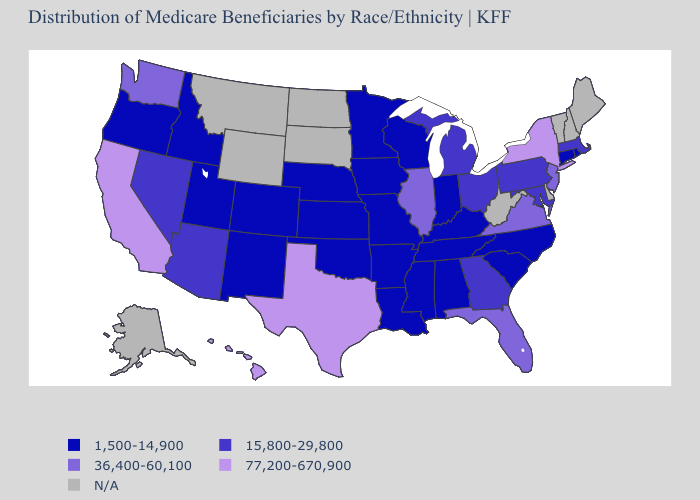Among the states that border Missouri , which have the highest value?
Short answer required. Illinois. Name the states that have a value in the range 77,200-670,900?
Give a very brief answer. California, Hawaii, New York, Texas. Which states have the lowest value in the West?
Answer briefly. Colorado, Idaho, New Mexico, Oregon, Utah. Name the states that have a value in the range 15,800-29,800?
Give a very brief answer. Arizona, Georgia, Maryland, Massachusetts, Michigan, Nevada, Ohio, Pennsylvania. What is the value of Kentucky?
Write a very short answer. 1,500-14,900. Name the states that have a value in the range 1,500-14,900?
Short answer required. Alabama, Arkansas, Colorado, Connecticut, Idaho, Indiana, Iowa, Kansas, Kentucky, Louisiana, Minnesota, Mississippi, Missouri, Nebraska, New Mexico, North Carolina, Oklahoma, Oregon, Rhode Island, South Carolina, Tennessee, Utah, Wisconsin. Which states have the lowest value in the USA?
Quick response, please. Alabama, Arkansas, Colorado, Connecticut, Idaho, Indiana, Iowa, Kansas, Kentucky, Louisiana, Minnesota, Mississippi, Missouri, Nebraska, New Mexico, North Carolina, Oklahoma, Oregon, Rhode Island, South Carolina, Tennessee, Utah, Wisconsin. What is the highest value in the Northeast ?
Concise answer only. 77,200-670,900. Among the states that border New Jersey , which have the highest value?
Keep it brief. New York. Name the states that have a value in the range 15,800-29,800?
Short answer required. Arizona, Georgia, Maryland, Massachusetts, Michigan, Nevada, Ohio, Pennsylvania. What is the value of Illinois?
Short answer required. 36,400-60,100. What is the value of Montana?
Concise answer only. N/A. Which states hav the highest value in the Northeast?
Concise answer only. New York. Among the states that border Florida , does Alabama have the highest value?
Short answer required. No. 